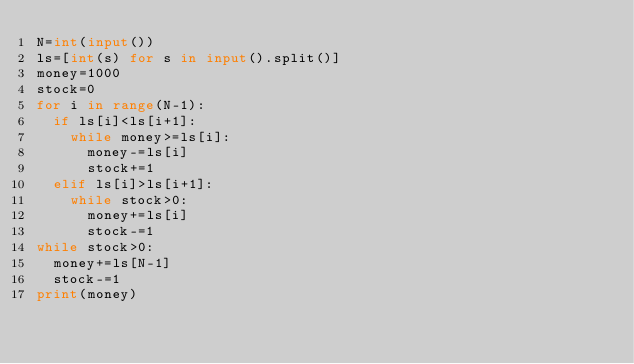<code> <loc_0><loc_0><loc_500><loc_500><_Python_>N=int(input())
ls=[int(s) for s in input().split()]
money=1000
stock=0
for i in range(N-1):
  if ls[i]<ls[i+1]:
    while money>=ls[i]:
      money-=ls[i]
      stock+=1
  elif ls[i]>ls[i+1]:
    while stock>0:
      money+=ls[i]
      stock-=1
while stock>0:
  money+=ls[N-1]
  stock-=1
print(money)</code> 